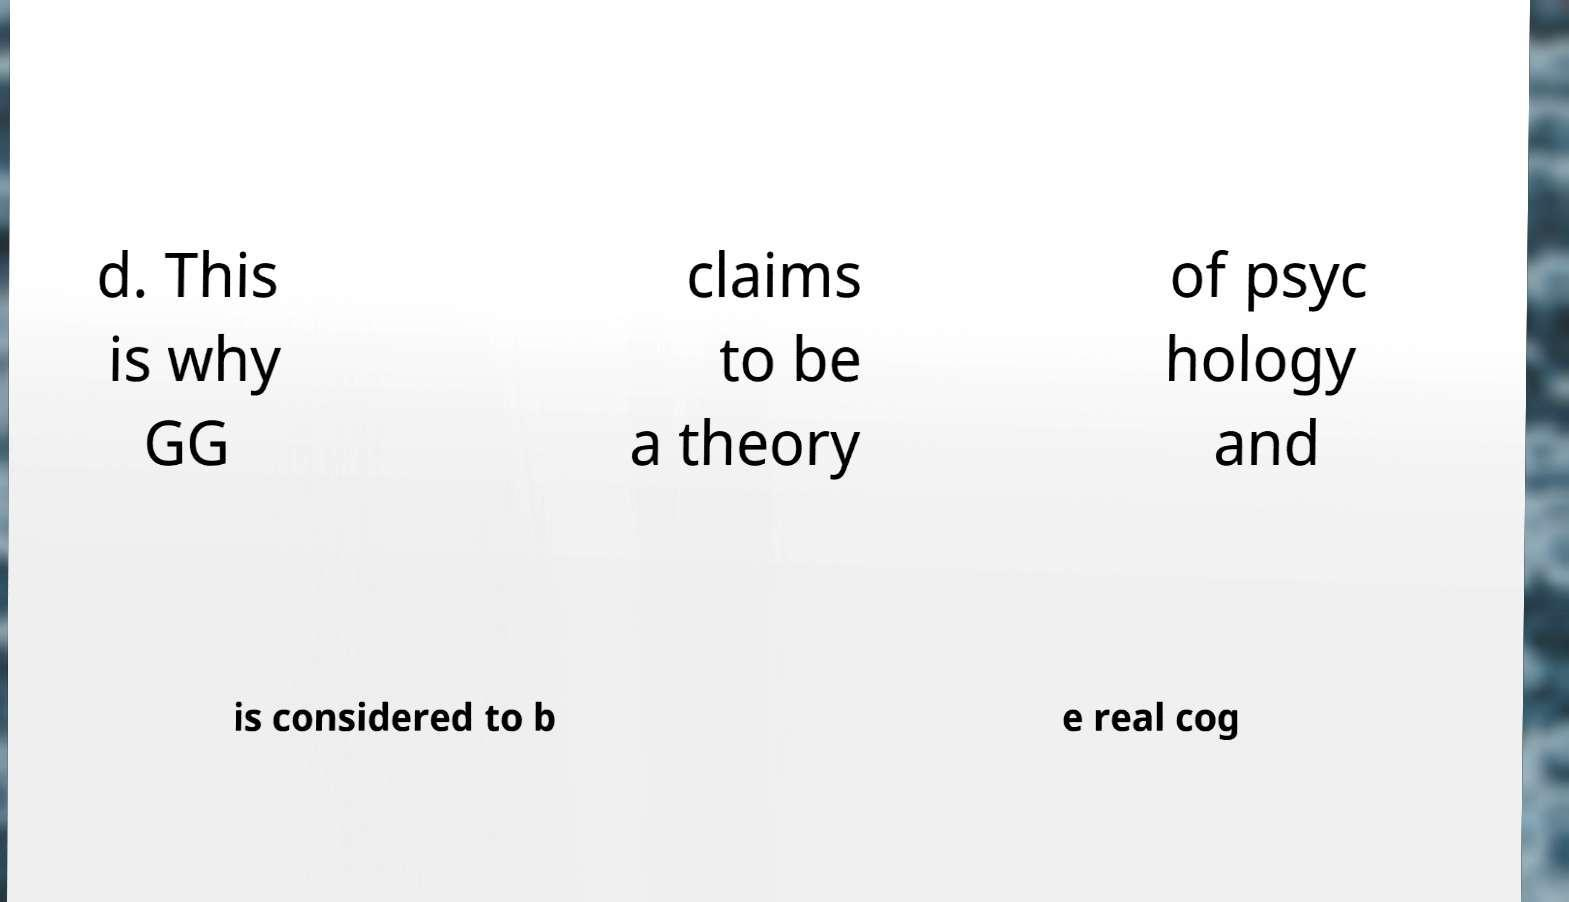Can you accurately transcribe the text from the provided image for me? d. This is why GG claims to be a theory of psyc hology and is considered to b e real cog 